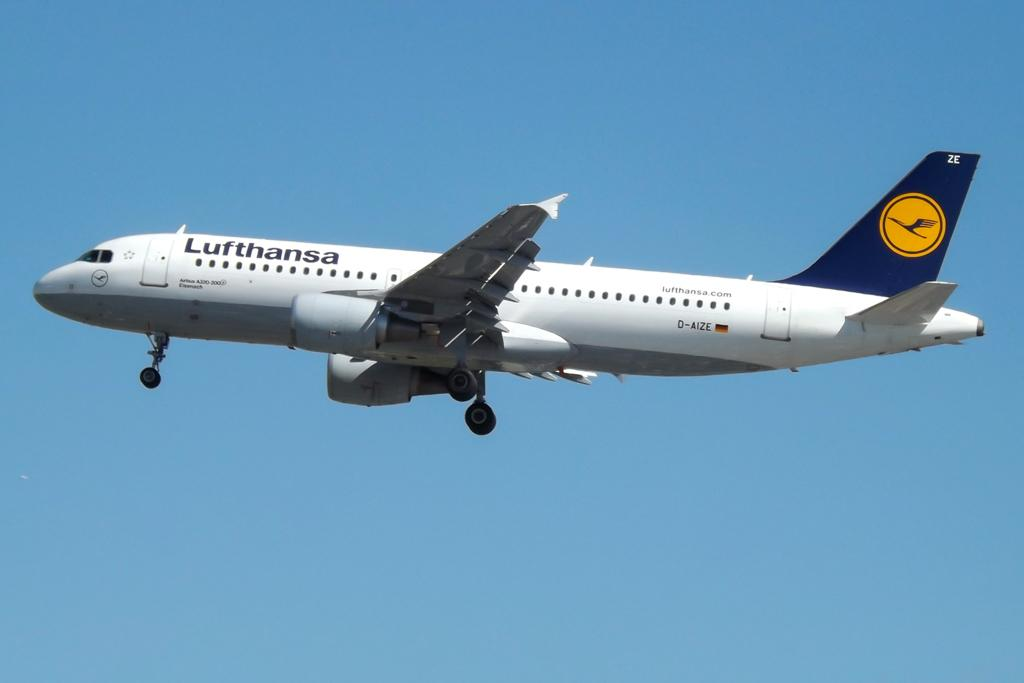Provide a one-sentence caption for the provided image. A large Lufthansa plane is flying through a clear blue sky. 